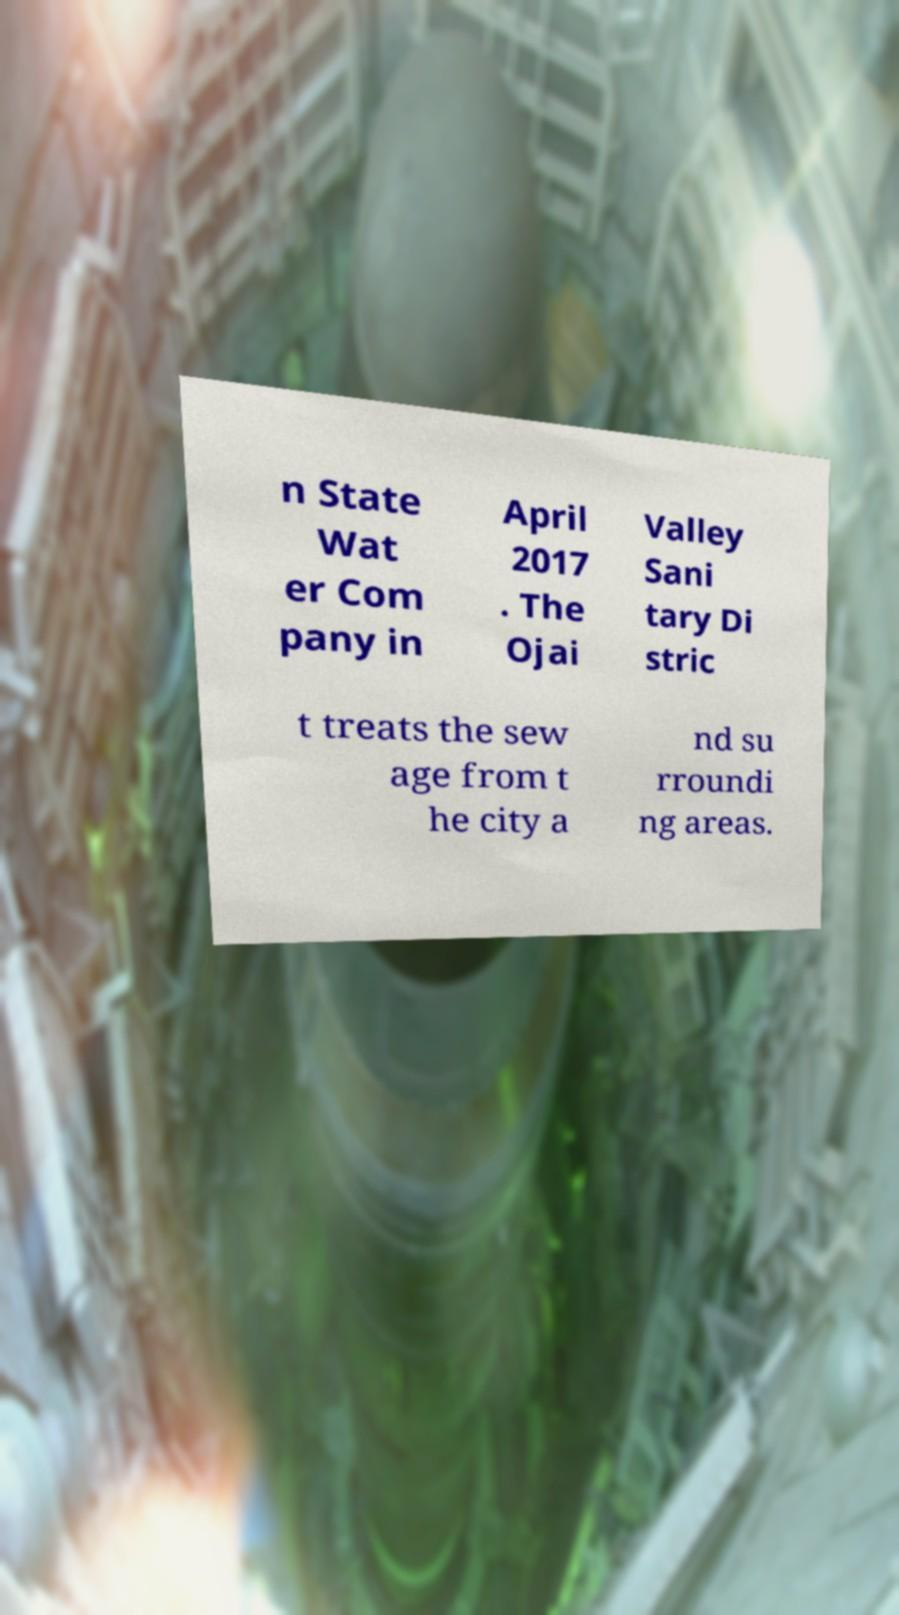Please identify and transcribe the text found in this image. n State Wat er Com pany in April 2017 . The Ojai Valley Sani tary Di stric t treats the sew age from t he city a nd su rroundi ng areas. 